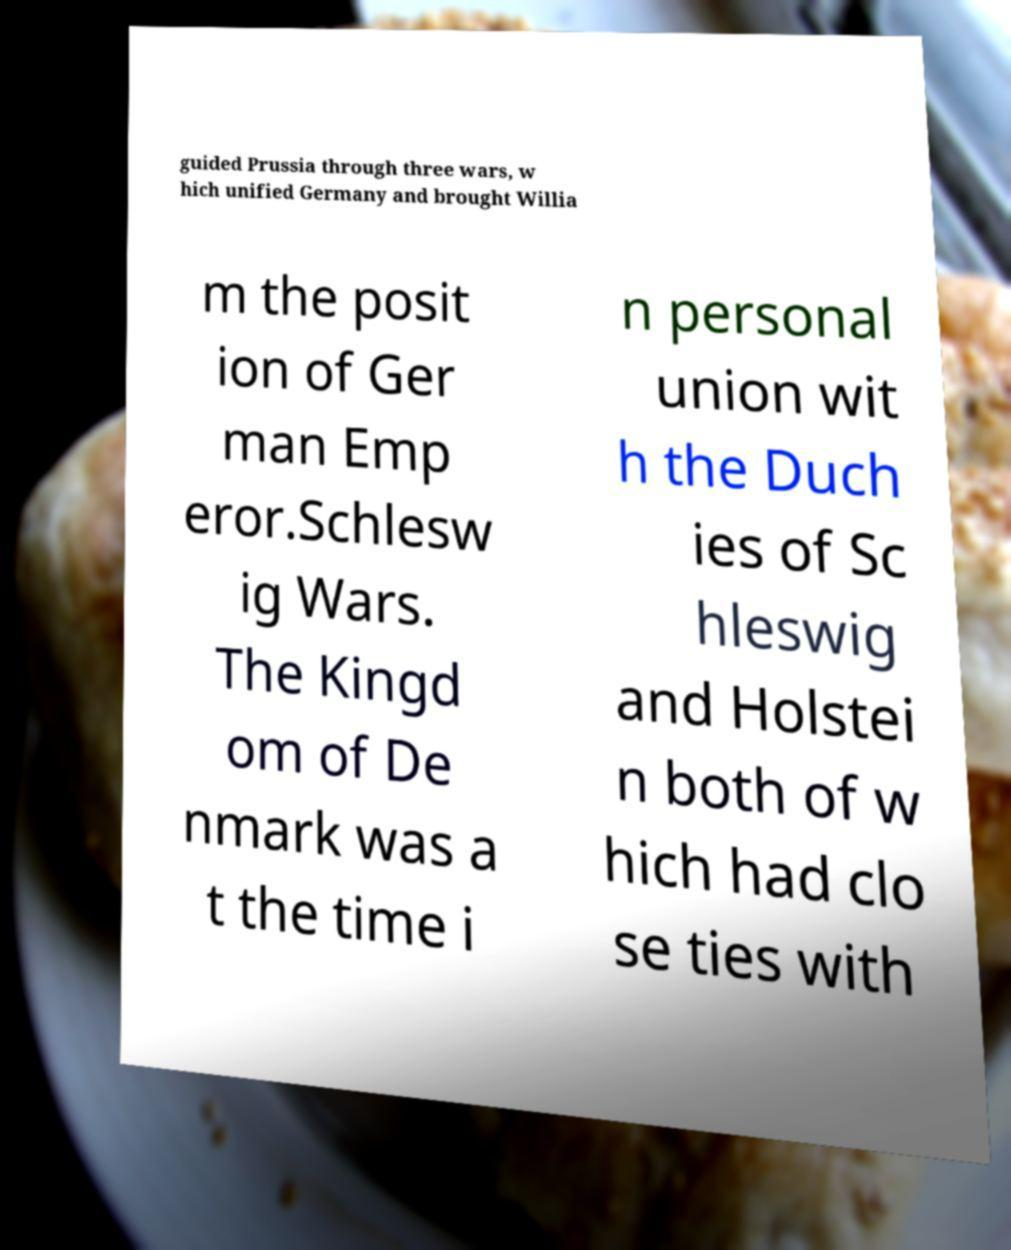What messages or text are displayed in this image? I need them in a readable, typed format. guided Prussia through three wars, w hich unified Germany and brought Willia m the posit ion of Ger man Emp eror.Schlesw ig Wars. The Kingd om of De nmark was a t the time i n personal union wit h the Duch ies of Sc hleswig and Holstei n both of w hich had clo se ties with 